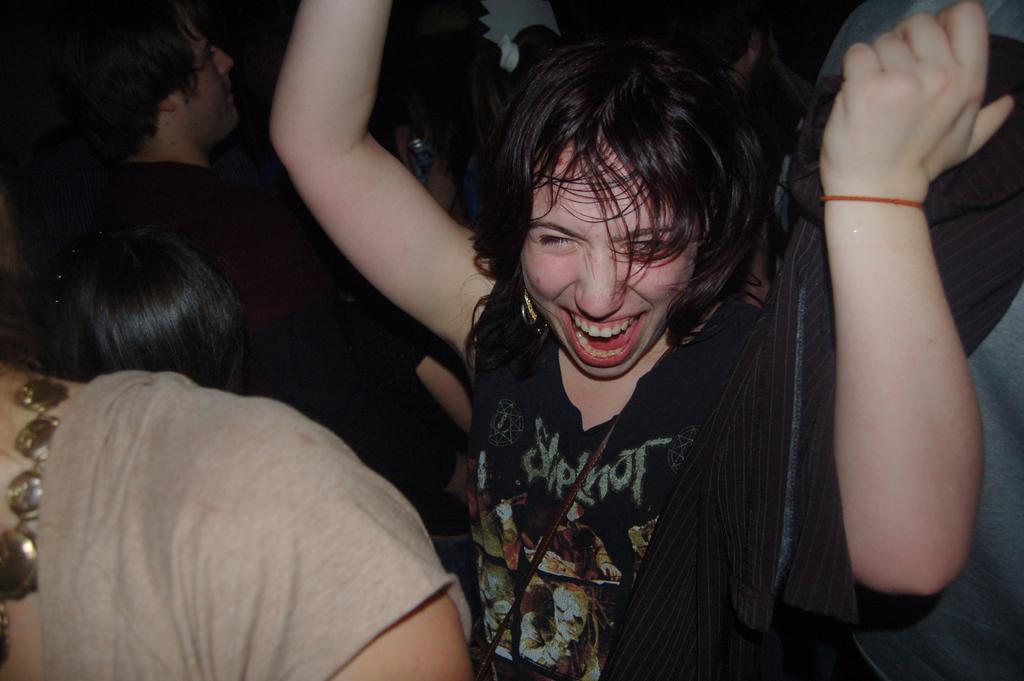Can you describe this image briefly? This is the picture of a group of people. And in front there is a person wearing black dress. 